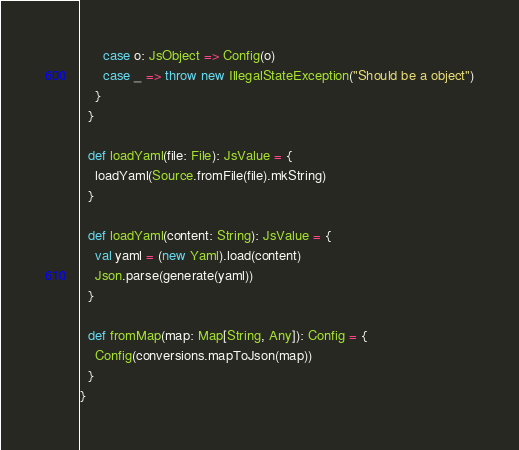Convert code to text. <code><loc_0><loc_0><loc_500><loc_500><_Scala_>      case o: JsObject => Config(o)
      case _ => throw new IllegalStateException("Should be a object")
    }
  }

  def loadYaml(file: File): JsValue = {
    loadYaml(Source.fromFile(file).mkString)
  }

  def loadYaml(content: String): JsValue = {
    val yaml = (new Yaml).load(content)
    Json.parse(generate(yaml))
  }

  def fromMap(map: Map[String, Any]): Config = {
    Config(conversions.mapToJson(map))
  }
}
</code> 